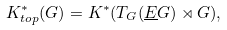<formula> <loc_0><loc_0><loc_500><loc_500>K ^ { * } _ { t o p } ( G ) = K ^ { * } ( T _ { G } ( \underline { E } G ) \rtimes G ) ,</formula> 